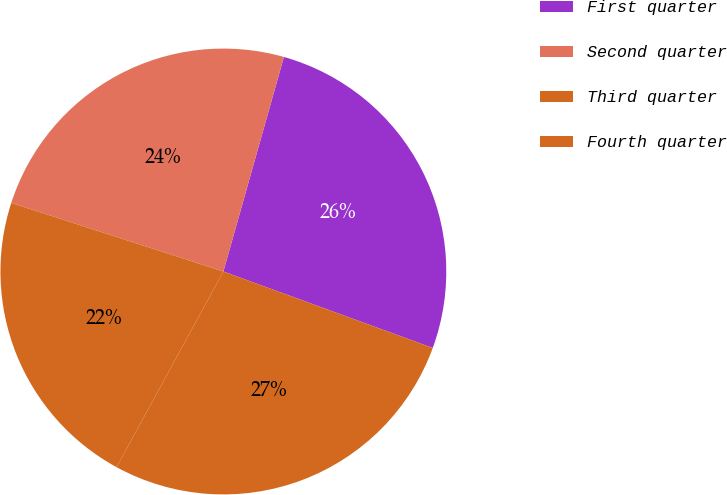<chart> <loc_0><loc_0><loc_500><loc_500><pie_chart><fcel>First quarter<fcel>Second quarter<fcel>Third quarter<fcel>Fourth quarter<nl><fcel>26.19%<fcel>24.4%<fcel>22.02%<fcel>27.38%<nl></chart> 